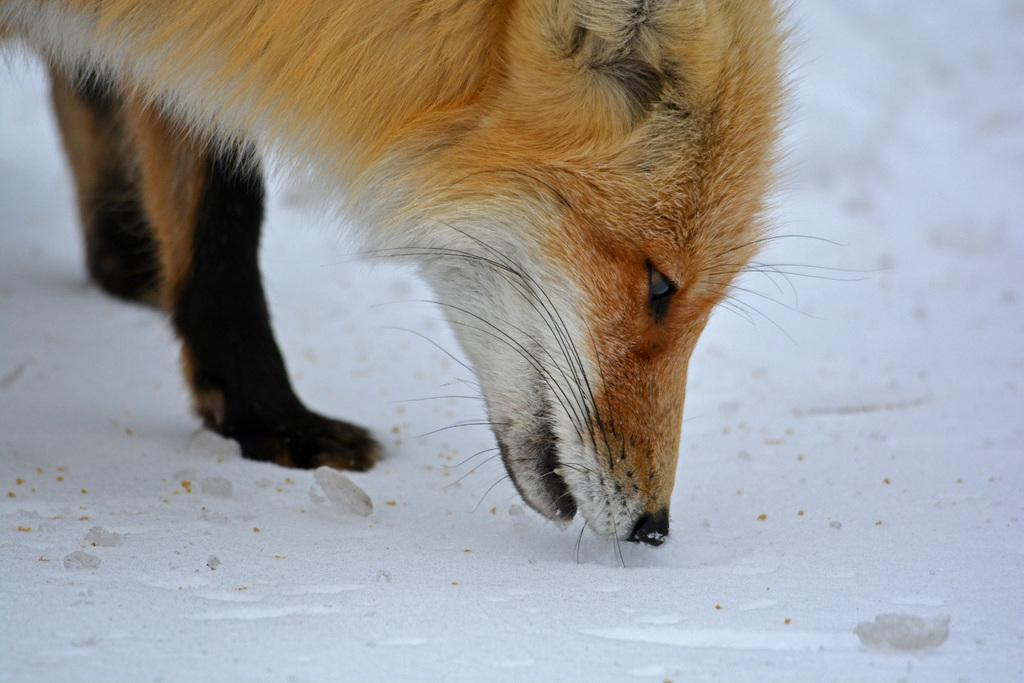What type of animal can be seen in the image? The image contains an animal, but the specific type of animal cannot be determined from the provided facts. What type of teeth can be seen on the appliance in the image? There is no appliance or teeth present in the image, as it only contains an animal on the surface. 